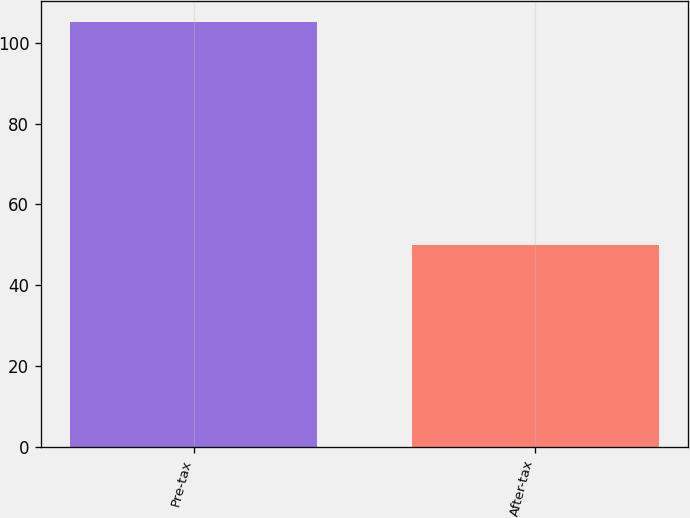<chart> <loc_0><loc_0><loc_500><loc_500><bar_chart><fcel>Pre-tax<fcel>After-tax<nl><fcel>105<fcel>50<nl></chart> 